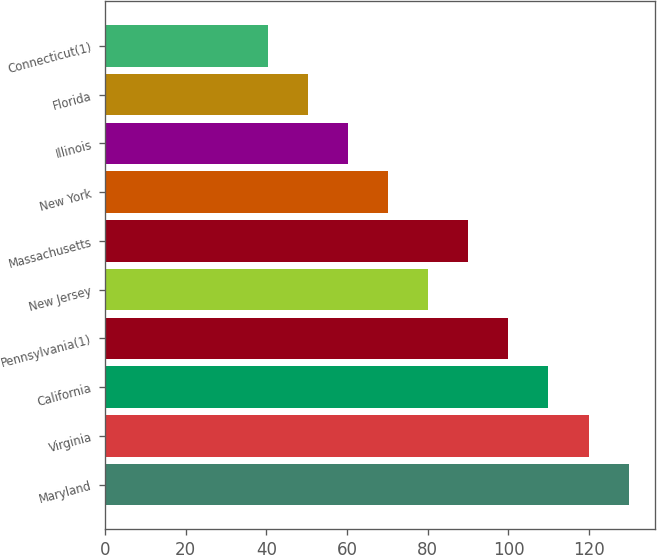<chart> <loc_0><loc_0><loc_500><loc_500><bar_chart><fcel>Maryland<fcel>Virginia<fcel>California<fcel>Pennsylvania(1)<fcel>New Jersey<fcel>Massachusetts<fcel>New York<fcel>Illinois<fcel>Florida<fcel>Connecticut(1)<nl><fcel>129.76<fcel>119.84<fcel>109.92<fcel>100<fcel>80.16<fcel>90.08<fcel>70.24<fcel>60.32<fcel>50.4<fcel>40.48<nl></chart> 